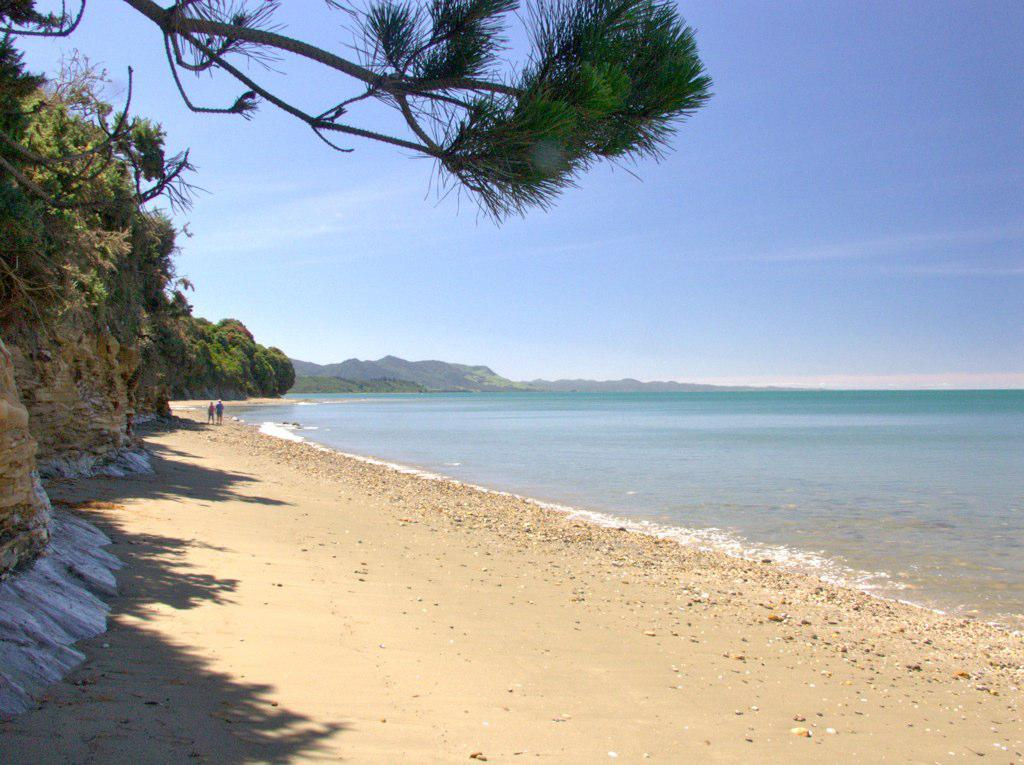What type of natural environment is depicted in the image? The image features trees, hills, and a seashore, indicating a coastal or beach setting. What can be seen in the water in the image? There are stones visible in the water in the image. What is the condition of the sky in the image? The sky is blue and cloudy in the image. What are the people in the image doing? The people in the image are standing on the seashore. How many horses are visible in the image? There are no horses present in the image. Can you tell me the total cost of the items purchased, as shown on the receipt in the image? There is no receipt present in the image. 